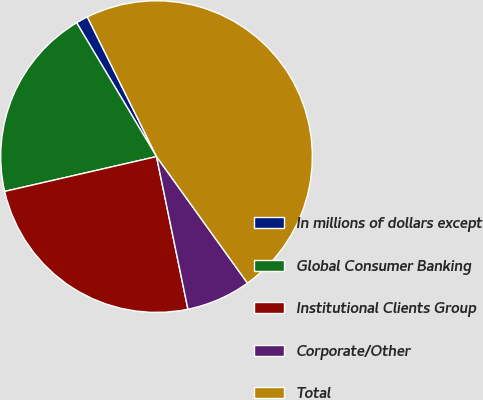Convert chart. <chart><loc_0><loc_0><loc_500><loc_500><pie_chart><fcel>In millions of dollars except<fcel>Global Consumer Banking<fcel>Institutional Clients Group<fcel>Corporate/Other<fcel>Total<nl><fcel>1.25%<fcel>20.02%<fcel>24.64%<fcel>6.69%<fcel>47.4%<nl></chart> 